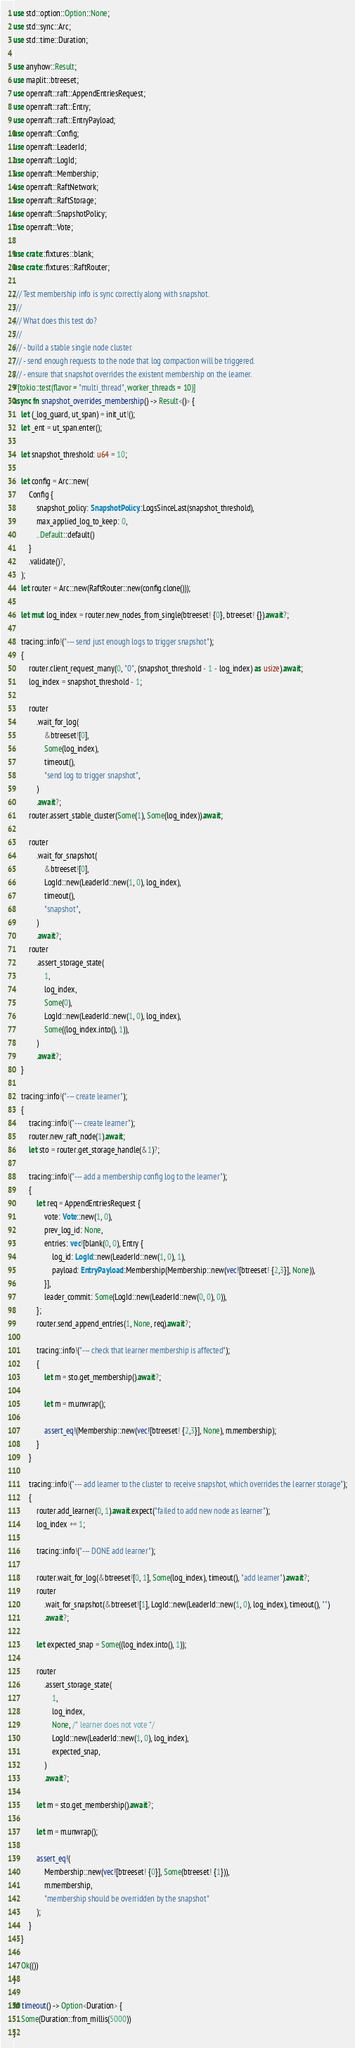Convert code to text. <code><loc_0><loc_0><loc_500><loc_500><_Rust_>use std::option::Option::None;
use std::sync::Arc;
use std::time::Duration;

use anyhow::Result;
use maplit::btreeset;
use openraft::raft::AppendEntriesRequest;
use openraft::raft::Entry;
use openraft::raft::EntryPayload;
use openraft::Config;
use openraft::LeaderId;
use openraft::LogId;
use openraft::Membership;
use openraft::RaftNetwork;
use openraft::RaftStorage;
use openraft::SnapshotPolicy;
use openraft::Vote;

use crate::fixtures::blank;
use crate::fixtures::RaftRouter;

/// Test membership info is sync correctly along with snapshot.
///
/// What does this test do?
///
/// - build a stable single node cluster.
/// - send enough requests to the node that log compaction will be triggered.
/// - ensure that snapshot overrides the existent membership on the learner.
#[tokio::test(flavor = "multi_thread", worker_threads = 10)]
async fn snapshot_overrides_membership() -> Result<()> {
    let (_log_guard, ut_span) = init_ut!();
    let _ent = ut_span.enter();

    let snapshot_threshold: u64 = 10;

    let config = Arc::new(
        Config {
            snapshot_policy: SnapshotPolicy::LogsSinceLast(snapshot_threshold),
            max_applied_log_to_keep: 0,
            ..Default::default()
        }
        .validate()?,
    );
    let router = Arc::new(RaftRouter::new(config.clone()));

    let mut log_index = router.new_nodes_from_single(btreeset! {0}, btreeset! {}).await?;

    tracing::info!("--- send just enough logs to trigger snapshot");
    {
        router.client_request_many(0, "0", (snapshot_threshold - 1 - log_index) as usize).await;
        log_index = snapshot_threshold - 1;

        router
            .wait_for_log(
                &btreeset![0],
                Some(log_index),
                timeout(),
                "send log to trigger snapshot",
            )
            .await?;
        router.assert_stable_cluster(Some(1), Some(log_index)).await;

        router
            .wait_for_snapshot(
                &btreeset![0],
                LogId::new(LeaderId::new(1, 0), log_index),
                timeout(),
                "snapshot",
            )
            .await?;
        router
            .assert_storage_state(
                1,
                log_index,
                Some(0),
                LogId::new(LeaderId::new(1, 0), log_index),
                Some((log_index.into(), 1)),
            )
            .await?;
    }

    tracing::info!("--- create learner");
    {
        tracing::info!("--- create learner");
        router.new_raft_node(1).await;
        let sto = router.get_storage_handle(&1)?;

        tracing::info!("--- add a membership config log to the learner");
        {
            let req = AppendEntriesRequest {
                vote: Vote::new(1, 0),
                prev_log_id: None,
                entries: vec![blank(0, 0), Entry {
                    log_id: LogId::new(LeaderId::new(1, 0), 1),
                    payload: EntryPayload::Membership(Membership::new(vec![btreeset! {2,3}], None)),
                }],
                leader_commit: Some(LogId::new(LeaderId::new(0, 0), 0)),
            };
            router.send_append_entries(1, None, req).await?;

            tracing::info!("--- check that learner membership is affected");
            {
                let m = sto.get_membership().await?;

                let m = m.unwrap();

                assert_eq!(Membership::new(vec![btreeset! {2,3}], None), m.membership);
            }
        }

        tracing::info!("--- add learner to the cluster to receive snapshot, which overrides the learner storage");
        {
            router.add_learner(0, 1).await.expect("failed to add new node as learner");
            log_index += 1;

            tracing::info!("--- DONE add learner");

            router.wait_for_log(&btreeset![0, 1], Some(log_index), timeout(), "add learner").await?;
            router
                .wait_for_snapshot(&btreeset![1], LogId::new(LeaderId::new(1, 0), log_index), timeout(), "")
                .await?;

            let expected_snap = Some((log_index.into(), 1));

            router
                .assert_storage_state(
                    1,
                    log_index,
                    None, /* learner does not vote */
                    LogId::new(LeaderId::new(1, 0), log_index),
                    expected_snap,
                )
                .await?;

            let m = sto.get_membership().await?;

            let m = m.unwrap();

            assert_eq!(
                Membership::new(vec![btreeset! {0}], Some(btreeset! {1})),
                m.membership,
                "membership should be overridden by the snapshot"
            );
        }
    }

    Ok(())
}

fn timeout() -> Option<Duration> {
    Some(Duration::from_millis(5000))
}
</code> 